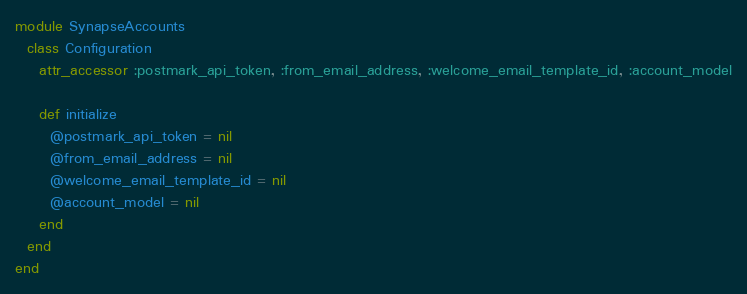<code> <loc_0><loc_0><loc_500><loc_500><_Ruby_>module SynapseAccounts
  class Configuration
    attr_accessor :postmark_api_token, :from_email_address, :welcome_email_template_id, :account_model

    def initialize
      @postmark_api_token = nil
      @from_email_address = nil
      @welcome_email_template_id = nil
      @account_model = nil
    end
  end
end
</code> 